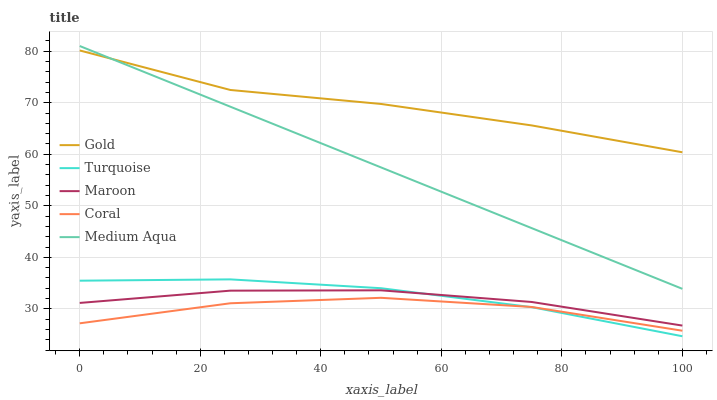Does Turquoise have the minimum area under the curve?
Answer yes or no. No. Does Turquoise have the maximum area under the curve?
Answer yes or no. No. Is Turquoise the smoothest?
Answer yes or no. No. Is Turquoise the roughest?
Answer yes or no. No. Does Medium Aqua have the lowest value?
Answer yes or no. No. Does Turquoise have the highest value?
Answer yes or no. No. Is Coral less than Medium Aqua?
Answer yes or no. Yes. Is Medium Aqua greater than Maroon?
Answer yes or no. Yes. Does Coral intersect Medium Aqua?
Answer yes or no. No. 